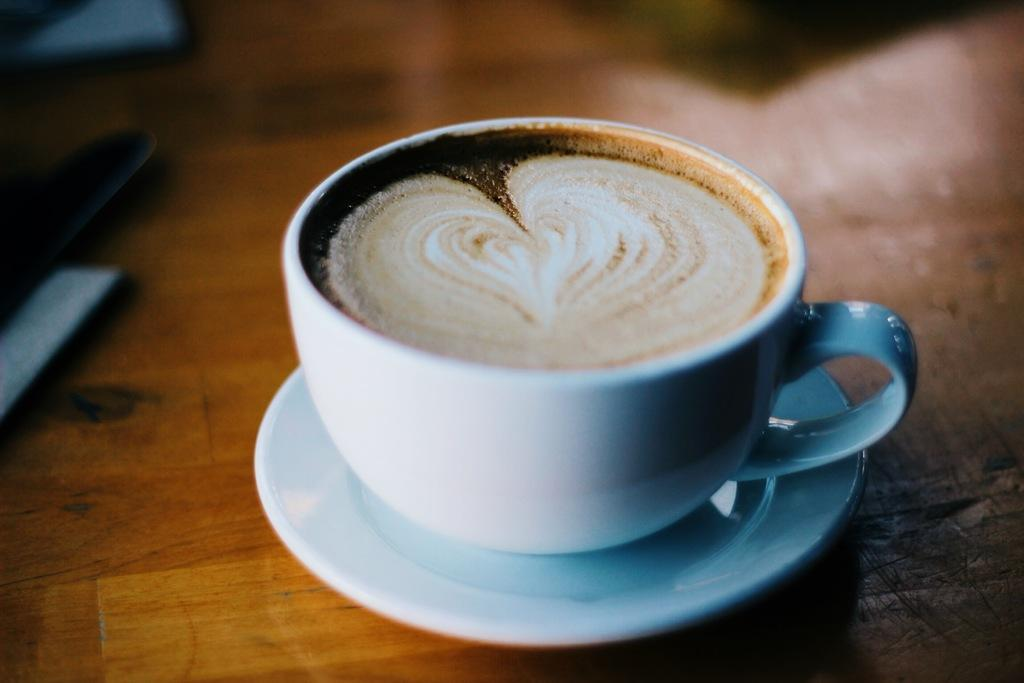What is on the table in the image? There is a cup with a saucer on the table in the image. What is inside the cup? There is liquid in the cup. Where is the cup and saucer placed? The cup and saucer are placed on a table. What else can be seen beside the cup and saucer? There is an object beside the cup and saucer. What type of letter is the goat holding in the image? There is no goat or letter present in the image. What is the color of the neck of the person in the image? There is no person present in the image, so it is not possible to determine the color of their neck. 